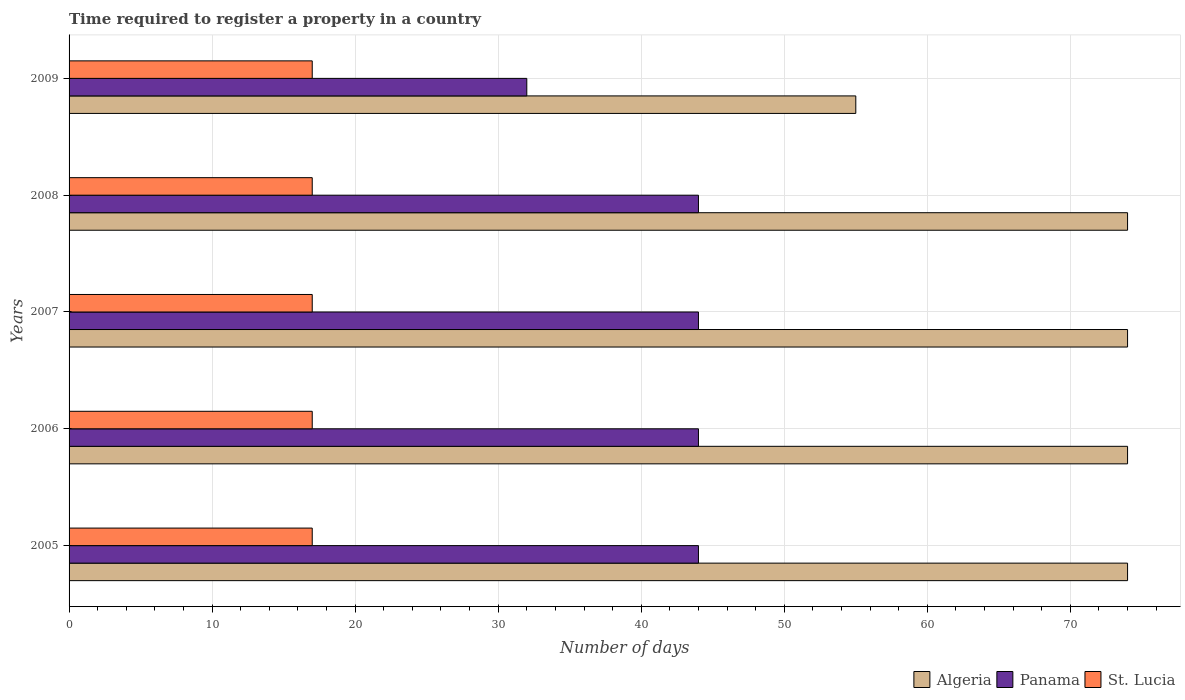How many bars are there on the 5th tick from the top?
Offer a terse response. 3. What is the number of days required to register a property in Algeria in 2005?
Your answer should be very brief. 74. Across all years, what is the maximum number of days required to register a property in Algeria?
Provide a short and direct response. 74. Across all years, what is the minimum number of days required to register a property in Algeria?
Keep it short and to the point. 55. In which year was the number of days required to register a property in St. Lucia minimum?
Your response must be concise. 2005. What is the total number of days required to register a property in Algeria in the graph?
Provide a succinct answer. 351. What is the difference between the number of days required to register a property in Algeria in 2005 and that in 2007?
Ensure brevity in your answer.  0. What is the difference between the number of days required to register a property in Panama in 2009 and the number of days required to register a property in St. Lucia in 2008?
Your answer should be very brief. 15. What is the average number of days required to register a property in Algeria per year?
Give a very brief answer. 70.2. In the year 2005, what is the difference between the number of days required to register a property in St. Lucia and number of days required to register a property in Panama?
Your response must be concise. -27. Is the number of days required to register a property in Algeria in 2006 less than that in 2008?
Offer a terse response. No. What is the difference between the highest and the second highest number of days required to register a property in Panama?
Your answer should be very brief. 0. What is the difference between the highest and the lowest number of days required to register a property in Panama?
Provide a succinct answer. 12. What does the 1st bar from the top in 2008 represents?
Offer a very short reply. St. Lucia. What does the 3rd bar from the bottom in 2009 represents?
Give a very brief answer. St. Lucia. How many bars are there?
Make the answer very short. 15. Are all the bars in the graph horizontal?
Provide a short and direct response. Yes. What is the difference between two consecutive major ticks on the X-axis?
Your answer should be very brief. 10. Are the values on the major ticks of X-axis written in scientific E-notation?
Offer a terse response. No. How many legend labels are there?
Your answer should be compact. 3. What is the title of the graph?
Ensure brevity in your answer.  Time required to register a property in a country. What is the label or title of the X-axis?
Offer a terse response. Number of days. What is the label or title of the Y-axis?
Make the answer very short. Years. What is the Number of days of St. Lucia in 2005?
Offer a terse response. 17. What is the Number of days of Panama in 2006?
Give a very brief answer. 44. What is the Number of days in St. Lucia in 2006?
Offer a very short reply. 17. What is the Number of days of Algeria in 2007?
Keep it short and to the point. 74. What is the Number of days in Algeria in 2009?
Your response must be concise. 55. What is the Number of days in Panama in 2009?
Make the answer very short. 32. What is the Number of days in St. Lucia in 2009?
Give a very brief answer. 17. Across all years, what is the minimum Number of days of Panama?
Your answer should be very brief. 32. What is the total Number of days of Algeria in the graph?
Keep it short and to the point. 351. What is the total Number of days of Panama in the graph?
Your response must be concise. 208. What is the difference between the Number of days of St. Lucia in 2005 and that in 2006?
Give a very brief answer. 0. What is the difference between the Number of days of Algeria in 2005 and that in 2007?
Give a very brief answer. 0. What is the difference between the Number of days of Panama in 2005 and that in 2007?
Provide a short and direct response. 0. What is the difference between the Number of days in St. Lucia in 2005 and that in 2008?
Your response must be concise. 0. What is the difference between the Number of days of Algeria in 2005 and that in 2009?
Offer a very short reply. 19. What is the difference between the Number of days of St. Lucia in 2005 and that in 2009?
Your answer should be compact. 0. What is the difference between the Number of days in Panama in 2006 and that in 2007?
Ensure brevity in your answer.  0. What is the difference between the Number of days in St. Lucia in 2006 and that in 2007?
Your response must be concise. 0. What is the difference between the Number of days of Panama in 2006 and that in 2008?
Give a very brief answer. 0. What is the difference between the Number of days of St. Lucia in 2006 and that in 2008?
Give a very brief answer. 0. What is the difference between the Number of days in St. Lucia in 2006 and that in 2009?
Give a very brief answer. 0. What is the difference between the Number of days in Algeria in 2007 and that in 2008?
Provide a succinct answer. 0. What is the difference between the Number of days of Panama in 2007 and that in 2008?
Offer a very short reply. 0. What is the difference between the Number of days in St. Lucia in 2007 and that in 2008?
Your answer should be very brief. 0. What is the difference between the Number of days in Panama in 2007 and that in 2009?
Your response must be concise. 12. What is the difference between the Number of days of St. Lucia in 2007 and that in 2009?
Provide a succinct answer. 0. What is the difference between the Number of days of Algeria in 2008 and that in 2009?
Make the answer very short. 19. What is the difference between the Number of days of Panama in 2008 and that in 2009?
Provide a succinct answer. 12. What is the difference between the Number of days of St. Lucia in 2008 and that in 2009?
Give a very brief answer. 0. What is the difference between the Number of days of Algeria in 2005 and the Number of days of St. Lucia in 2006?
Your answer should be very brief. 57. What is the difference between the Number of days in Algeria in 2005 and the Number of days in St. Lucia in 2007?
Ensure brevity in your answer.  57. What is the difference between the Number of days in Algeria in 2005 and the Number of days in Panama in 2008?
Your response must be concise. 30. What is the difference between the Number of days in Algeria in 2005 and the Number of days in St. Lucia in 2008?
Keep it short and to the point. 57. What is the difference between the Number of days of Panama in 2005 and the Number of days of St. Lucia in 2008?
Offer a very short reply. 27. What is the difference between the Number of days of Algeria in 2005 and the Number of days of Panama in 2009?
Keep it short and to the point. 42. What is the difference between the Number of days in Algeria in 2006 and the Number of days in Panama in 2007?
Provide a short and direct response. 30. What is the difference between the Number of days of Algeria in 2006 and the Number of days of St. Lucia in 2007?
Offer a terse response. 57. What is the difference between the Number of days in Panama in 2006 and the Number of days in St. Lucia in 2007?
Make the answer very short. 27. What is the difference between the Number of days of Algeria in 2006 and the Number of days of St. Lucia in 2008?
Offer a very short reply. 57. What is the difference between the Number of days in Algeria in 2007 and the Number of days in St. Lucia in 2008?
Provide a short and direct response. 57. What is the difference between the Number of days in Panama in 2007 and the Number of days in St. Lucia in 2009?
Your answer should be compact. 27. What is the difference between the Number of days of Algeria in 2008 and the Number of days of Panama in 2009?
Your response must be concise. 42. What is the average Number of days in Algeria per year?
Offer a very short reply. 70.2. What is the average Number of days in Panama per year?
Your answer should be compact. 41.6. What is the average Number of days of St. Lucia per year?
Offer a terse response. 17. In the year 2005, what is the difference between the Number of days in Algeria and Number of days in St. Lucia?
Make the answer very short. 57. In the year 2005, what is the difference between the Number of days of Panama and Number of days of St. Lucia?
Give a very brief answer. 27. In the year 2006, what is the difference between the Number of days of Algeria and Number of days of Panama?
Make the answer very short. 30. In the year 2006, what is the difference between the Number of days in Algeria and Number of days in St. Lucia?
Provide a succinct answer. 57. In the year 2007, what is the difference between the Number of days of Algeria and Number of days of Panama?
Your answer should be very brief. 30. In the year 2007, what is the difference between the Number of days of Algeria and Number of days of St. Lucia?
Provide a succinct answer. 57. In the year 2007, what is the difference between the Number of days of Panama and Number of days of St. Lucia?
Your response must be concise. 27. In the year 2008, what is the difference between the Number of days of Algeria and Number of days of Panama?
Provide a succinct answer. 30. In the year 2008, what is the difference between the Number of days of Algeria and Number of days of St. Lucia?
Offer a very short reply. 57. In the year 2009, what is the difference between the Number of days of Algeria and Number of days of Panama?
Provide a succinct answer. 23. In the year 2009, what is the difference between the Number of days of Panama and Number of days of St. Lucia?
Keep it short and to the point. 15. What is the ratio of the Number of days in Algeria in 2005 to that in 2006?
Your response must be concise. 1. What is the ratio of the Number of days in St. Lucia in 2005 to that in 2006?
Make the answer very short. 1. What is the ratio of the Number of days in Panama in 2005 to that in 2007?
Give a very brief answer. 1. What is the ratio of the Number of days of Algeria in 2005 to that in 2008?
Provide a succinct answer. 1. What is the ratio of the Number of days of St. Lucia in 2005 to that in 2008?
Offer a very short reply. 1. What is the ratio of the Number of days of Algeria in 2005 to that in 2009?
Make the answer very short. 1.35. What is the ratio of the Number of days in Panama in 2005 to that in 2009?
Provide a succinct answer. 1.38. What is the ratio of the Number of days of Algeria in 2006 to that in 2007?
Keep it short and to the point. 1. What is the ratio of the Number of days of St. Lucia in 2006 to that in 2007?
Offer a very short reply. 1. What is the ratio of the Number of days in Algeria in 2006 to that in 2009?
Offer a very short reply. 1.35. What is the ratio of the Number of days in Panama in 2006 to that in 2009?
Your answer should be very brief. 1.38. What is the ratio of the Number of days of St. Lucia in 2007 to that in 2008?
Provide a short and direct response. 1. What is the ratio of the Number of days of Algeria in 2007 to that in 2009?
Make the answer very short. 1.35. What is the ratio of the Number of days in Panama in 2007 to that in 2009?
Provide a succinct answer. 1.38. What is the ratio of the Number of days of St. Lucia in 2007 to that in 2009?
Keep it short and to the point. 1. What is the ratio of the Number of days in Algeria in 2008 to that in 2009?
Provide a short and direct response. 1.35. What is the ratio of the Number of days in Panama in 2008 to that in 2009?
Provide a succinct answer. 1.38. What is the ratio of the Number of days in St. Lucia in 2008 to that in 2009?
Provide a succinct answer. 1. What is the difference between the highest and the second highest Number of days of Algeria?
Ensure brevity in your answer.  0. What is the difference between the highest and the second highest Number of days of Panama?
Provide a short and direct response. 0. What is the difference between the highest and the lowest Number of days of Panama?
Provide a succinct answer. 12. What is the difference between the highest and the lowest Number of days of St. Lucia?
Your answer should be very brief. 0. 